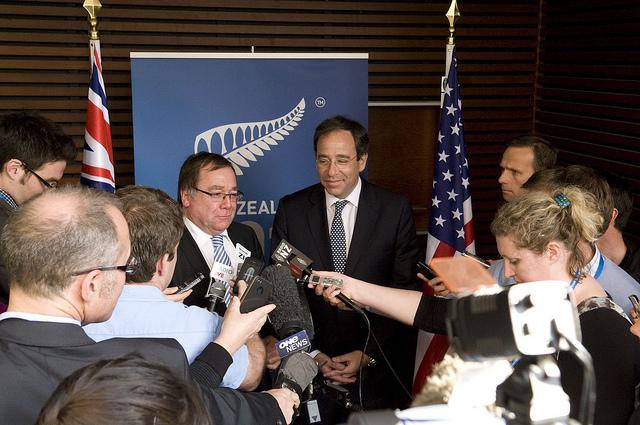How many flags are there?
Short answer required. 2. Is this a government meeting?
Be succinct. Yes. Why are the people holding out microphones?
Be succinct. Speech. 